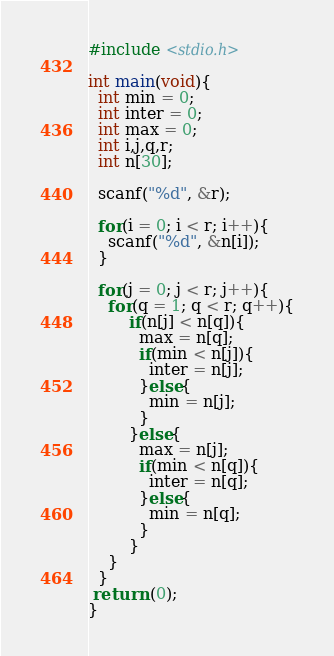<code> <loc_0><loc_0><loc_500><loc_500><_C_>#include <stdio.h>

int main(void){
  int min = 0;
  int inter = 0;
  int max = 0;
  int i,j,q,r;
  int n[30];
  
  scanf("%d", &r);
  
  for(i = 0; i < r; i++){
    scanf("%d", &n[i]);
  }
  
  for(j = 0; j < r; j++){
    for(q = 1; q < r; q++){
    	if(n[j] < n[q]){
          max = n[q];
          if(min < n[j]){
            inter = n[j];
          }else{
            min = n[j];
          }
        }else{
          max = n[j];
          if(min < n[q]){
            inter = n[q];
          }else{
            min = n[q];
          }
        }
    }
  }
 return (0);
}</code> 